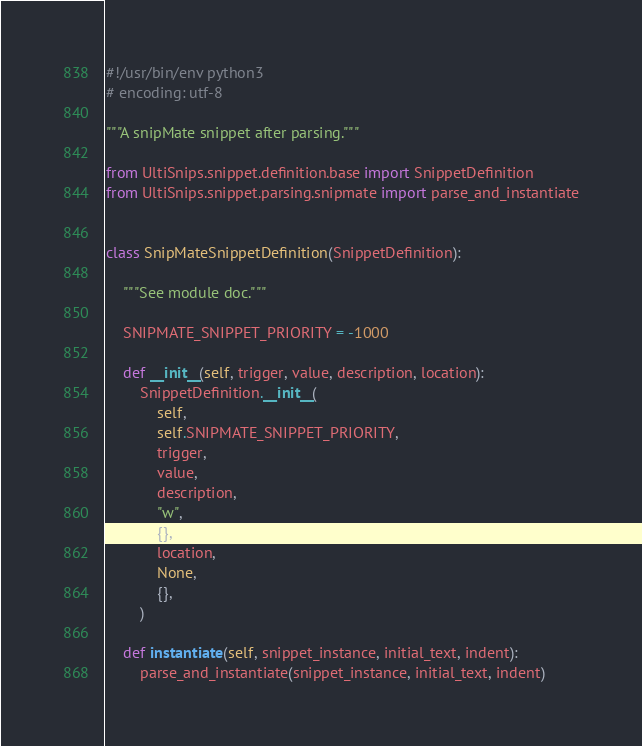Convert code to text. <code><loc_0><loc_0><loc_500><loc_500><_Python_>#!/usr/bin/env python3
# encoding: utf-8

"""A snipMate snippet after parsing."""

from UltiSnips.snippet.definition.base import SnippetDefinition
from UltiSnips.snippet.parsing.snipmate import parse_and_instantiate


class SnipMateSnippetDefinition(SnippetDefinition):

    """See module doc."""

    SNIPMATE_SNIPPET_PRIORITY = -1000

    def __init__(self, trigger, value, description, location):
        SnippetDefinition.__init__(
            self,
            self.SNIPMATE_SNIPPET_PRIORITY,
            trigger,
            value,
            description,
            "w",
            {},
            location,
            None,
            {},
        )

    def instantiate(self, snippet_instance, initial_text, indent):
        parse_and_instantiate(snippet_instance, initial_text, indent)
</code> 